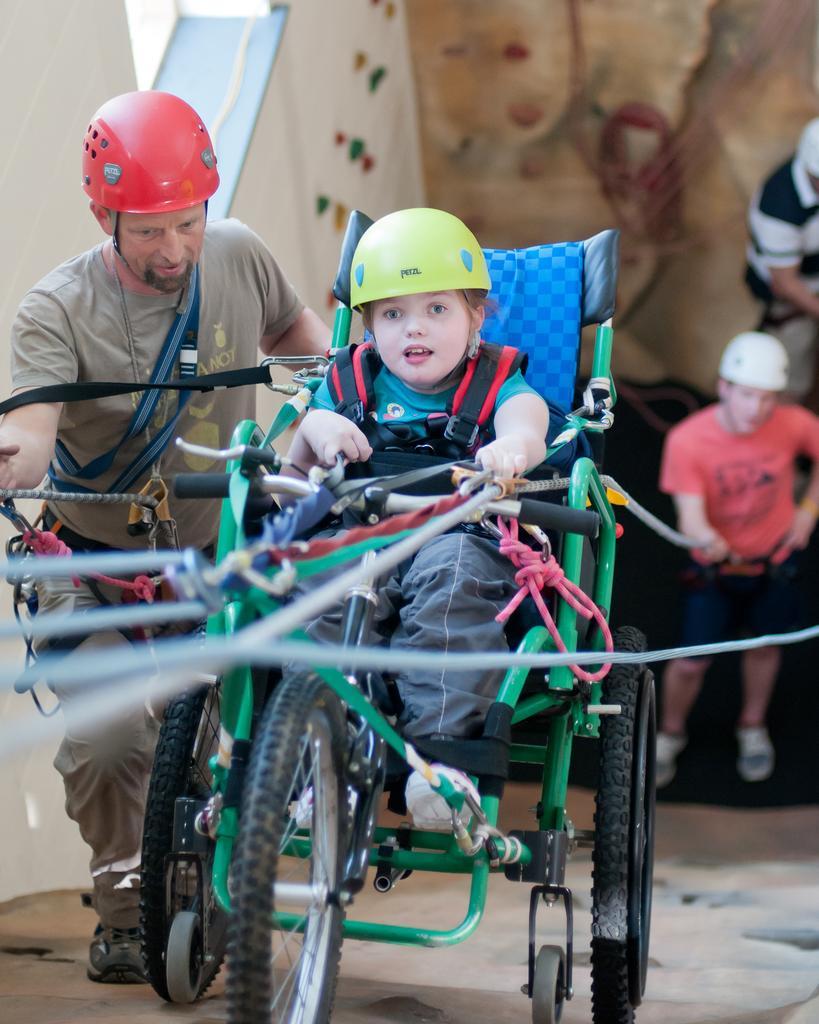How would you summarize this image in a sentence or two? In this image we can see a child sitting in a vehicle. We can also see some people standing. In that two men are holding the ropes. We can also see a wall. 